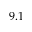Convert formula to latex. <formula><loc_0><loc_0><loc_500><loc_500>9 . 1</formula> 